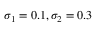Convert formula to latex. <formula><loc_0><loc_0><loc_500><loc_500>\sigma _ { 1 } = 0 . 1 , \sigma _ { 2 } = 0 . 3</formula> 